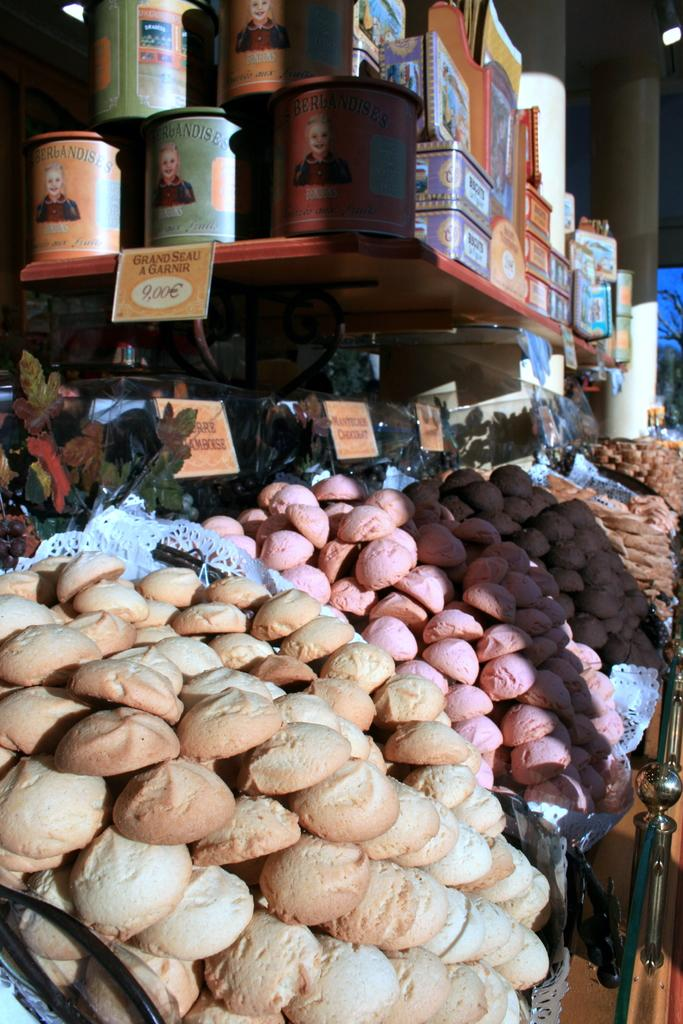What type of food item is visible in the image? The specific type of food item is not mentioned, but there is a food item in the image. What can be seen on the wooden table in the image? There are tins and boxes on the wooden table in the image. What are the tags used for in the image? The purpose of the tags in the image is not specified, but they are present. Can you describe the light in the image? The details about the light in the image are not provided, but there is a light present. What type of square insect can be seen crawling on the food item in the image? There is no square insect present in the image, and no insect is mentioned in the facts. 